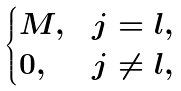<formula> <loc_0><loc_0><loc_500><loc_500>\begin{cases} M , & j = l , \\ 0 , & j \ne l , \end{cases}</formula> 